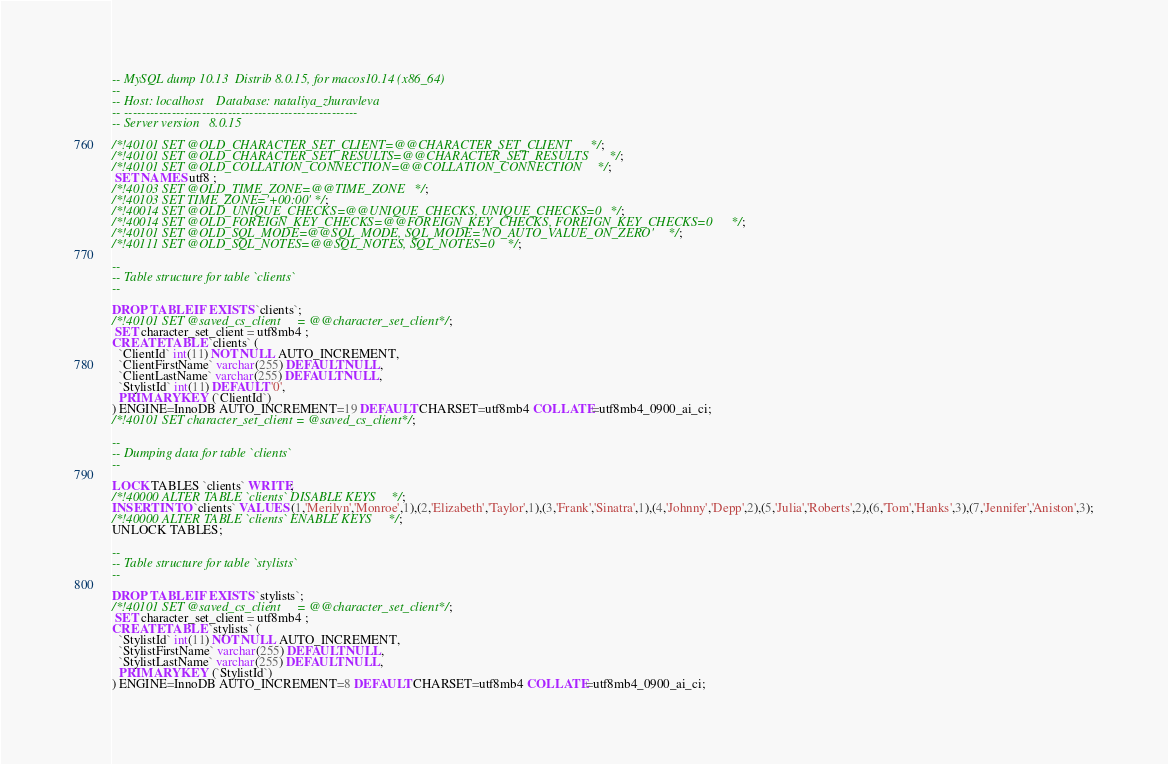<code> <loc_0><loc_0><loc_500><loc_500><_SQL_>-- MySQL dump 10.13  Distrib 8.0.15, for macos10.14 (x86_64)
--
-- Host: localhost    Database: nataliya_zhuravleva
-- ------------------------------------------------------
-- Server version	8.0.15

/*!40101 SET @OLD_CHARACTER_SET_CLIENT=@@CHARACTER_SET_CLIENT */;
/*!40101 SET @OLD_CHARACTER_SET_RESULTS=@@CHARACTER_SET_RESULTS */;
/*!40101 SET @OLD_COLLATION_CONNECTION=@@COLLATION_CONNECTION */;
 SET NAMES utf8 ;
/*!40103 SET @OLD_TIME_ZONE=@@TIME_ZONE */;
/*!40103 SET TIME_ZONE='+00:00' */;
/*!40014 SET @OLD_UNIQUE_CHECKS=@@UNIQUE_CHECKS, UNIQUE_CHECKS=0 */;
/*!40014 SET @OLD_FOREIGN_KEY_CHECKS=@@FOREIGN_KEY_CHECKS, FOREIGN_KEY_CHECKS=0 */;
/*!40101 SET @OLD_SQL_MODE=@@SQL_MODE, SQL_MODE='NO_AUTO_VALUE_ON_ZERO' */;
/*!40111 SET @OLD_SQL_NOTES=@@SQL_NOTES, SQL_NOTES=0 */;

--
-- Table structure for table `clients`
--

DROP TABLE IF EXISTS `clients`;
/*!40101 SET @saved_cs_client     = @@character_set_client */;
 SET character_set_client = utf8mb4 ;
CREATE TABLE `clients` (
  `ClientId` int(11) NOT NULL AUTO_INCREMENT,
  `ClientFirstName` varchar(255) DEFAULT NULL,
  `ClientLastName` varchar(255) DEFAULT NULL,
  `StylistId` int(11) DEFAULT '0',
  PRIMARY KEY (`ClientId`)
) ENGINE=InnoDB AUTO_INCREMENT=19 DEFAULT CHARSET=utf8mb4 COLLATE=utf8mb4_0900_ai_ci;
/*!40101 SET character_set_client = @saved_cs_client */;

--
-- Dumping data for table `clients`
--

LOCK TABLES `clients` WRITE;
/*!40000 ALTER TABLE `clients` DISABLE KEYS */;
INSERT INTO `clients` VALUES (1,'Merilyn','Monroe',1),(2,'Elizabeth','Taylor',1),(3,'Frank','Sinatra',1),(4,'Johnny','Depp',2),(5,'Julia','Roberts',2),(6,'Tom','Hanks',3),(7,'Jennifer','Aniston',3);
/*!40000 ALTER TABLE `clients` ENABLE KEYS */;
UNLOCK TABLES;

--
-- Table structure for table `stylists`
--

DROP TABLE IF EXISTS `stylists`;
/*!40101 SET @saved_cs_client     = @@character_set_client */;
 SET character_set_client = utf8mb4 ;
CREATE TABLE `stylists` (
  `StylistId` int(11) NOT NULL AUTO_INCREMENT,
  `StylistFirstName` varchar(255) DEFAULT NULL,
  `StylistLastName` varchar(255) DEFAULT NULL,
  PRIMARY KEY (`StylistId`)
) ENGINE=InnoDB AUTO_INCREMENT=8 DEFAULT CHARSET=utf8mb4 COLLATE=utf8mb4_0900_ai_ci;</code> 